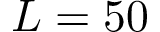<formula> <loc_0><loc_0><loc_500><loc_500>L = 5 0</formula> 